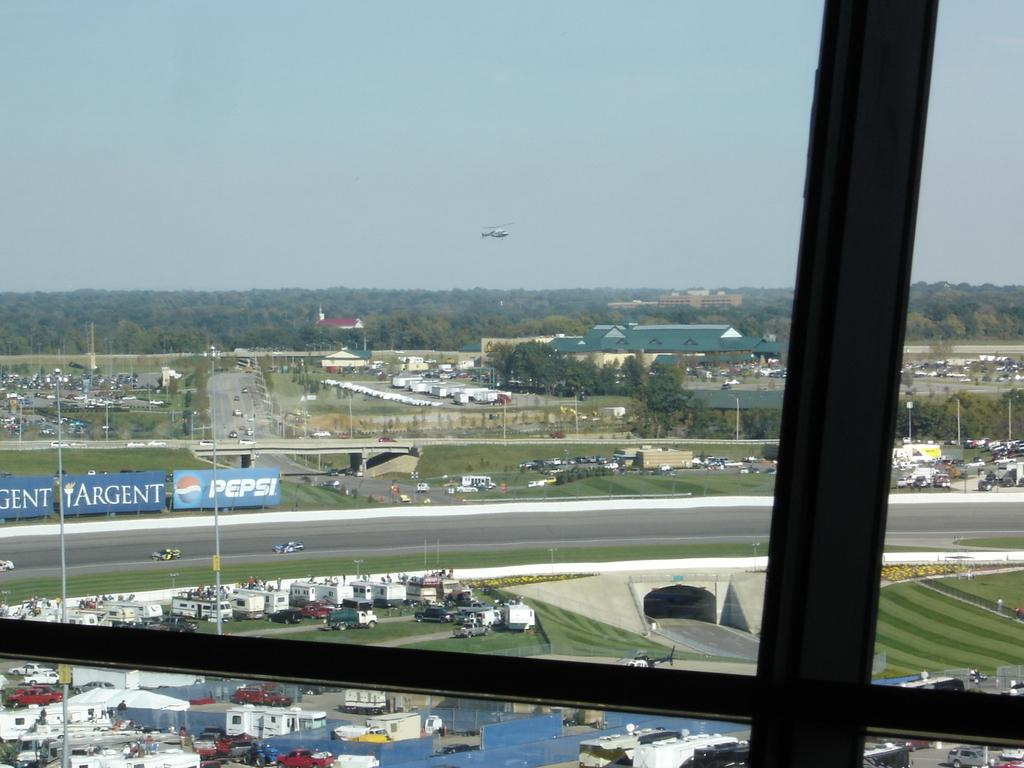Provide a one-sentence caption for the provided image. An aerial view of parked cars with a nearby Pepsi banner. 